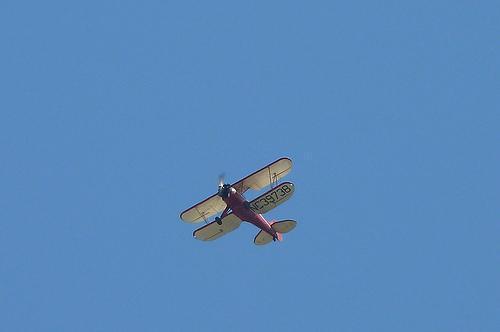How many planes are there?
Give a very brief answer. 1. How many wheels are there?
Give a very brief answer. 2. 